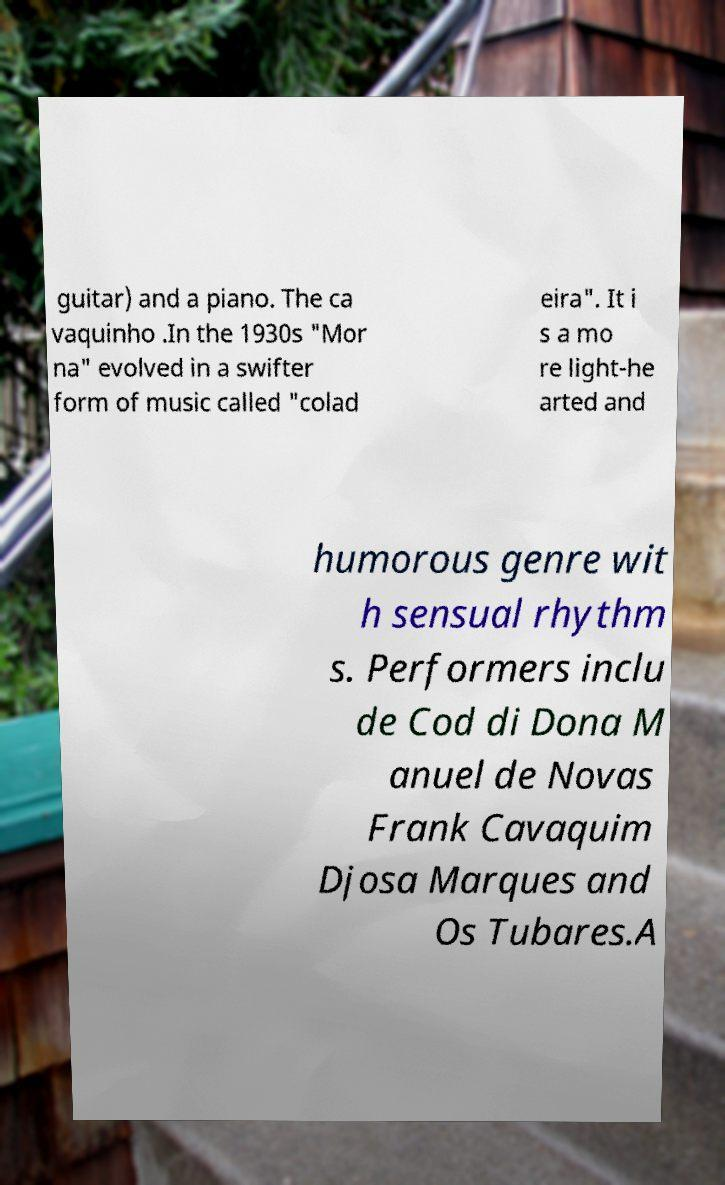For documentation purposes, I need the text within this image transcribed. Could you provide that? guitar) and a piano. The ca vaquinho .In the 1930s "Mor na" evolved in a swifter form of music called "colad eira". It i s a mo re light-he arted and humorous genre wit h sensual rhythm s. Performers inclu de Cod di Dona M anuel de Novas Frank Cavaquim Djosa Marques and Os Tubares.A 